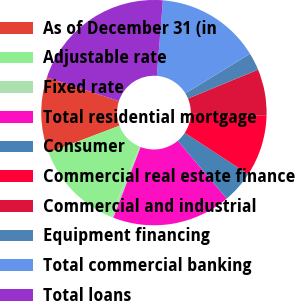Convert chart. <chart><loc_0><loc_0><loc_500><loc_500><pie_chart><fcel>As of December 31 (in<fcel>Adjustable rate<fcel>Fixed rate<fcel>Total residential mortgage<fcel>Consumer<fcel>Commercial real estate finance<fcel>Commercial and industrial<fcel>Equipment financing<fcel>Total commercial banking<fcel>Total loans<nl><fcel>10.83%<fcel>12.91%<fcel>0.45%<fcel>17.06%<fcel>4.6%<fcel>8.75%<fcel>6.68%<fcel>2.52%<fcel>14.99%<fcel>21.22%<nl></chart> 